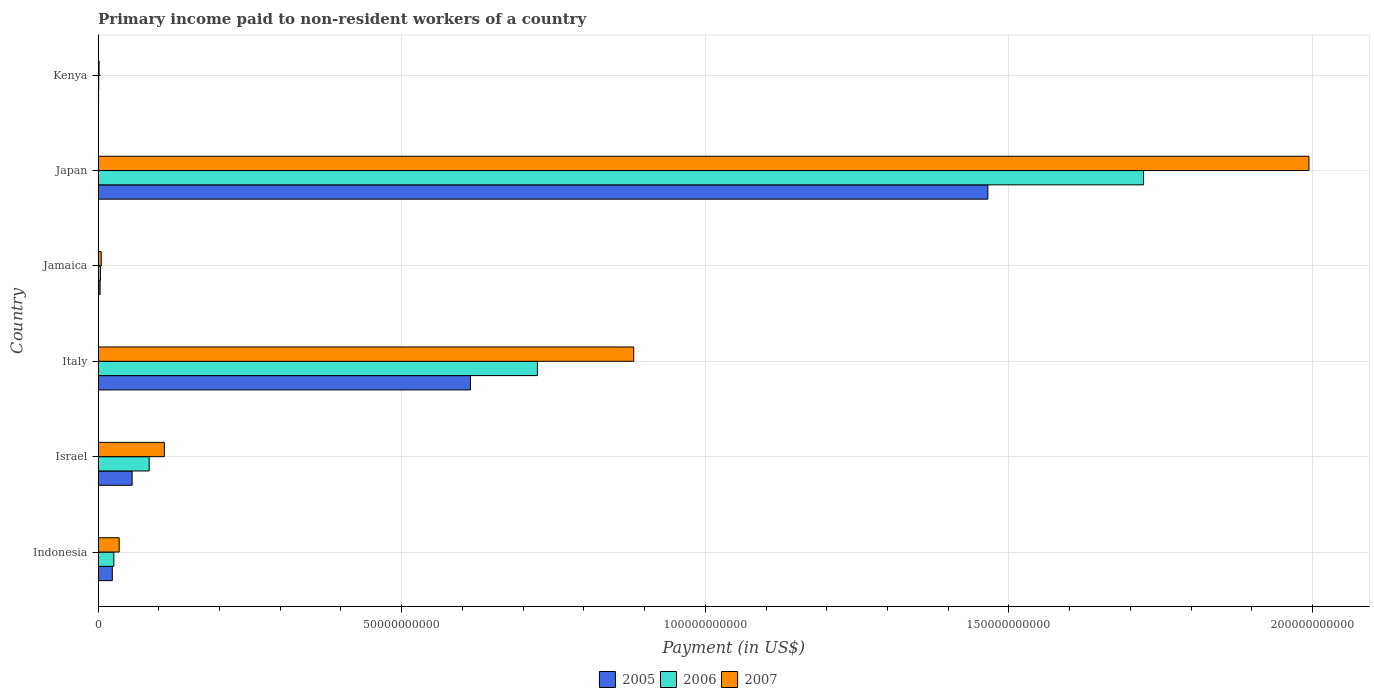How many different coloured bars are there?
Ensure brevity in your answer.  3. Are the number of bars per tick equal to the number of legend labels?
Offer a very short reply. Yes. Are the number of bars on each tick of the Y-axis equal?
Make the answer very short. Yes. How many bars are there on the 5th tick from the bottom?
Ensure brevity in your answer.  3. What is the label of the 5th group of bars from the top?
Your answer should be compact. Israel. In how many cases, is the number of bars for a given country not equal to the number of legend labels?
Your answer should be very brief. 0. What is the amount paid to workers in 2005 in Japan?
Your response must be concise. 1.47e+11. Across all countries, what is the maximum amount paid to workers in 2006?
Your answer should be compact. 1.72e+11. Across all countries, what is the minimum amount paid to workers in 2007?
Give a very brief answer. 1.61e+08. In which country was the amount paid to workers in 2006 maximum?
Keep it short and to the point. Japan. In which country was the amount paid to workers in 2005 minimum?
Provide a short and direct response. Kenya. What is the total amount paid to workers in 2005 in the graph?
Make the answer very short. 2.16e+11. What is the difference between the amount paid to workers in 2006 in Jamaica and that in Japan?
Provide a short and direct response. -1.72e+11. What is the difference between the amount paid to workers in 2005 in Israel and the amount paid to workers in 2006 in Kenya?
Provide a succinct answer. 5.50e+09. What is the average amount paid to workers in 2006 per country?
Ensure brevity in your answer.  4.27e+1. What is the difference between the amount paid to workers in 2006 and amount paid to workers in 2005 in Kenya?
Offer a terse response. 2.62e+07. What is the ratio of the amount paid to workers in 2005 in Italy to that in Japan?
Provide a short and direct response. 0.42. Is the amount paid to workers in 2007 in Indonesia less than that in Japan?
Offer a terse response. Yes. Is the difference between the amount paid to workers in 2006 in Jamaica and Kenya greater than the difference between the amount paid to workers in 2005 in Jamaica and Kenya?
Provide a short and direct response. Yes. What is the difference between the highest and the second highest amount paid to workers in 2005?
Your response must be concise. 8.52e+1. What is the difference between the highest and the lowest amount paid to workers in 2005?
Provide a succinct answer. 1.46e+11. In how many countries, is the amount paid to workers in 2006 greater than the average amount paid to workers in 2006 taken over all countries?
Your answer should be compact. 2. What does the 1st bar from the top in Israel represents?
Provide a short and direct response. 2007. What does the 3rd bar from the bottom in Kenya represents?
Your answer should be very brief. 2007. How many bars are there?
Your answer should be very brief. 18. Are all the bars in the graph horizontal?
Make the answer very short. Yes. How many countries are there in the graph?
Provide a short and direct response. 6. Does the graph contain grids?
Provide a succinct answer. Yes. Where does the legend appear in the graph?
Your answer should be very brief. Bottom center. How are the legend labels stacked?
Your answer should be compact. Horizontal. What is the title of the graph?
Provide a succinct answer. Primary income paid to non-resident workers of a country. Does "1976" appear as one of the legend labels in the graph?
Provide a short and direct response. No. What is the label or title of the X-axis?
Provide a short and direct response. Payment (in US$). What is the Payment (in US$) of 2005 in Indonesia?
Give a very brief answer. 2.34e+09. What is the Payment (in US$) of 2006 in Indonesia?
Your response must be concise. 2.59e+09. What is the Payment (in US$) of 2007 in Indonesia?
Your answer should be very brief. 3.47e+09. What is the Payment (in US$) of 2005 in Israel?
Your response must be concise. 5.60e+09. What is the Payment (in US$) of 2006 in Israel?
Provide a short and direct response. 8.41e+09. What is the Payment (in US$) in 2007 in Israel?
Offer a terse response. 1.09e+1. What is the Payment (in US$) in 2005 in Italy?
Your answer should be very brief. 6.13e+1. What is the Payment (in US$) in 2006 in Italy?
Provide a succinct answer. 7.24e+1. What is the Payment (in US$) in 2007 in Italy?
Provide a succinct answer. 8.82e+1. What is the Payment (in US$) of 2005 in Jamaica?
Give a very brief answer. 3.28e+08. What is the Payment (in US$) of 2006 in Jamaica?
Your answer should be very brief. 3.78e+08. What is the Payment (in US$) of 2007 in Jamaica?
Your answer should be compact. 5.21e+08. What is the Payment (in US$) in 2005 in Japan?
Make the answer very short. 1.47e+11. What is the Payment (in US$) in 2006 in Japan?
Offer a very short reply. 1.72e+11. What is the Payment (in US$) of 2007 in Japan?
Your answer should be very brief. 1.99e+11. What is the Payment (in US$) in 2005 in Kenya?
Your answer should be very brief. 7.33e+07. What is the Payment (in US$) in 2006 in Kenya?
Your answer should be compact. 9.94e+07. What is the Payment (in US$) in 2007 in Kenya?
Keep it short and to the point. 1.61e+08. Across all countries, what is the maximum Payment (in US$) in 2005?
Offer a very short reply. 1.47e+11. Across all countries, what is the maximum Payment (in US$) of 2006?
Keep it short and to the point. 1.72e+11. Across all countries, what is the maximum Payment (in US$) in 2007?
Give a very brief answer. 1.99e+11. Across all countries, what is the minimum Payment (in US$) of 2005?
Your answer should be compact. 7.33e+07. Across all countries, what is the minimum Payment (in US$) in 2006?
Your answer should be very brief. 9.94e+07. Across all countries, what is the minimum Payment (in US$) of 2007?
Provide a short and direct response. 1.61e+08. What is the total Payment (in US$) of 2005 in the graph?
Offer a terse response. 2.16e+11. What is the total Payment (in US$) in 2006 in the graph?
Make the answer very short. 2.56e+11. What is the total Payment (in US$) of 2007 in the graph?
Make the answer very short. 3.03e+11. What is the difference between the Payment (in US$) of 2005 in Indonesia and that in Israel?
Ensure brevity in your answer.  -3.26e+09. What is the difference between the Payment (in US$) of 2006 in Indonesia and that in Israel?
Your response must be concise. -5.82e+09. What is the difference between the Payment (in US$) of 2007 in Indonesia and that in Israel?
Ensure brevity in your answer.  -7.44e+09. What is the difference between the Payment (in US$) in 2005 in Indonesia and that in Italy?
Your answer should be compact. -5.90e+1. What is the difference between the Payment (in US$) in 2006 in Indonesia and that in Italy?
Offer a very short reply. -6.98e+1. What is the difference between the Payment (in US$) of 2007 in Indonesia and that in Italy?
Ensure brevity in your answer.  -8.47e+1. What is the difference between the Payment (in US$) in 2005 in Indonesia and that in Jamaica?
Provide a succinct answer. 2.01e+09. What is the difference between the Payment (in US$) of 2006 in Indonesia and that in Jamaica?
Your response must be concise. 2.21e+09. What is the difference between the Payment (in US$) of 2007 in Indonesia and that in Jamaica?
Give a very brief answer. 2.95e+09. What is the difference between the Payment (in US$) of 2005 in Indonesia and that in Japan?
Ensure brevity in your answer.  -1.44e+11. What is the difference between the Payment (in US$) of 2006 in Indonesia and that in Japan?
Give a very brief answer. -1.70e+11. What is the difference between the Payment (in US$) in 2007 in Indonesia and that in Japan?
Offer a terse response. -1.96e+11. What is the difference between the Payment (in US$) in 2005 in Indonesia and that in Kenya?
Your response must be concise. 2.26e+09. What is the difference between the Payment (in US$) of 2006 in Indonesia and that in Kenya?
Provide a short and direct response. 2.49e+09. What is the difference between the Payment (in US$) in 2007 in Indonesia and that in Kenya?
Offer a terse response. 3.31e+09. What is the difference between the Payment (in US$) of 2005 in Israel and that in Italy?
Your response must be concise. -5.57e+1. What is the difference between the Payment (in US$) in 2006 in Israel and that in Italy?
Your answer should be very brief. -6.39e+1. What is the difference between the Payment (in US$) of 2007 in Israel and that in Italy?
Your answer should be compact. -7.73e+1. What is the difference between the Payment (in US$) of 2005 in Israel and that in Jamaica?
Offer a terse response. 5.27e+09. What is the difference between the Payment (in US$) in 2006 in Israel and that in Jamaica?
Offer a terse response. 8.03e+09. What is the difference between the Payment (in US$) in 2007 in Israel and that in Jamaica?
Your answer should be very brief. 1.04e+1. What is the difference between the Payment (in US$) in 2005 in Israel and that in Japan?
Ensure brevity in your answer.  -1.41e+11. What is the difference between the Payment (in US$) of 2006 in Israel and that in Japan?
Keep it short and to the point. -1.64e+11. What is the difference between the Payment (in US$) in 2007 in Israel and that in Japan?
Give a very brief answer. -1.89e+11. What is the difference between the Payment (in US$) in 2005 in Israel and that in Kenya?
Your answer should be very brief. 5.53e+09. What is the difference between the Payment (in US$) in 2006 in Israel and that in Kenya?
Provide a succinct answer. 8.31e+09. What is the difference between the Payment (in US$) in 2007 in Israel and that in Kenya?
Ensure brevity in your answer.  1.07e+1. What is the difference between the Payment (in US$) in 2005 in Italy and that in Jamaica?
Offer a terse response. 6.10e+1. What is the difference between the Payment (in US$) of 2006 in Italy and that in Jamaica?
Offer a very short reply. 7.20e+1. What is the difference between the Payment (in US$) in 2007 in Italy and that in Jamaica?
Keep it short and to the point. 8.77e+1. What is the difference between the Payment (in US$) in 2005 in Italy and that in Japan?
Offer a terse response. -8.52e+1. What is the difference between the Payment (in US$) in 2006 in Italy and that in Japan?
Give a very brief answer. -9.98e+1. What is the difference between the Payment (in US$) in 2007 in Italy and that in Japan?
Your response must be concise. -1.11e+11. What is the difference between the Payment (in US$) of 2005 in Italy and that in Kenya?
Make the answer very short. 6.12e+1. What is the difference between the Payment (in US$) in 2006 in Italy and that in Kenya?
Provide a short and direct response. 7.23e+1. What is the difference between the Payment (in US$) of 2007 in Italy and that in Kenya?
Your response must be concise. 8.81e+1. What is the difference between the Payment (in US$) in 2005 in Jamaica and that in Japan?
Your answer should be compact. -1.46e+11. What is the difference between the Payment (in US$) of 2006 in Jamaica and that in Japan?
Offer a very short reply. -1.72e+11. What is the difference between the Payment (in US$) of 2007 in Jamaica and that in Japan?
Provide a short and direct response. -1.99e+11. What is the difference between the Payment (in US$) in 2005 in Jamaica and that in Kenya?
Keep it short and to the point. 2.55e+08. What is the difference between the Payment (in US$) in 2006 in Jamaica and that in Kenya?
Keep it short and to the point. 2.79e+08. What is the difference between the Payment (in US$) in 2007 in Jamaica and that in Kenya?
Provide a short and direct response. 3.60e+08. What is the difference between the Payment (in US$) of 2005 in Japan and that in Kenya?
Provide a succinct answer. 1.46e+11. What is the difference between the Payment (in US$) in 2006 in Japan and that in Kenya?
Your answer should be very brief. 1.72e+11. What is the difference between the Payment (in US$) in 2007 in Japan and that in Kenya?
Your answer should be compact. 1.99e+11. What is the difference between the Payment (in US$) of 2005 in Indonesia and the Payment (in US$) of 2006 in Israel?
Your response must be concise. -6.07e+09. What is the difference between the Payment (in US$) of 2005 in Indonesia and the Payment (in US$) of 2007 in Israel?
Your response must be concise. -8.57e+09. What is the difference between the Payment (in US$) of 2006 in Indonesia and the Payment (in US$) of 2007 in Israel?
Keep it short and to the point. -8.32e+09. What is the difference between the Payment (in US$) of 2005 in Indonesia and the Payment (in US$) of 2006 in Italy?
Keep it short and to the point. -7.00e+1. What is the difference between the Payment (in US$) of 2005 in Indonesia and the Payment (in US$) of 2007 in Italy?
Give a very brief answer. -8.59e+1. What is the difference between the Payment (in US$) of 2006 in Indonesia and the Payment (in US$) of 2007 in Italy?
Provide a short and direct response. -8.56e+1. What is the difference between the Payment (in US$) of 2005 in Indonesia and the Payment (in US$) of 2006 in Jamaica?
Offer a very short reply. 1.96e+09. What is the difference between the Payment (in US$) in 2005 in Indonesia and the Payment (in US$) in 2007 in Jamaica?
Keep it short and to the point. 1.82e+09. What is the difference between the Payment (in US$) of 2006 in Indonesia and the Payment (in US$) of 2007 in Jamaica?
Provide a succinct answer. 2.07e+09. What is the difference between the Payment (in US$) of 2005 in Indonesia and the Payment (in US$) of 2006 in Japan?
Keep it short and to the point. -1.70e+11. What is the difference between the Payment (in US$) in 2005 in Indonesia and the Payment (in US$) in 2007 in Japan?
Keep it short and to the point. -1.97e+11. What is the difference between the Payment (in US$) of 2006 in Indonesia and the Payment (in US$) of 2007 in Japan?
Offer a very short reply. -1.97e+11. What is the difference between the Payment (in US$) in 2005 in Indonesia and the Payment (in US$) in 2006 in Kenya?
Provide a succinct answer. 2.24e+09. What is the difference between the Payment (in US$) of 2005 in Indonesia and the Payment (in US$) of 2007 in Kenya?
Provide a short and direct response. 2.18e+09. What is the difference between the Payment (in US$) in 2006 in Indonesia and the Payment (in US$) in 2007 in Kenya?
Offer a very short reply. 2.43e+09. What is the difference between the Payment (in US$) in 2005 in Israel and the Payment (in US$) in 2006 in Italy?
Provide a short and direct response. -6.67e+1. What is the difference between the Payment (in US$) of 2005 in Israel and the Payment (in US$) of 2007 in Italy?
Provide a succinct answer. -8.26e+1. What is the difference between the Payment (in US$) of 2006 in Israel and the Payment (in US$) of 2007 in Italy?
Offer a very short reply. -7.98e+1. What is the difference between the Payment (in US$) of 2005 in Israel and the Payment (in US$) of 2006 in Jamaica?
Your answer should be very brief. 5.22e+09. What is the difference between the Payment (in US$) in 2005 in Israel and the Payment (in US$) in 2007 in Jamaica?
Give a very brief answer. 5.08e+09. What is the difference between the Payment (in US$) in 2006 in Israel and the Payment (in US$) in 2007 in Jamaica?
Your response must be concise. 7.89e+09. What is the difference between the Payment (in US$) of 2005 in Israel and the Payment (in US$) of 2006 in Japan?
Make the answer very short. -1.67e+11. What is the difference between the Payment (in US$) in 2005 in Israel and the Payment (in US$) in 2007 in Japan?
Give a very brief answer. -1.94e+11. What is the difference between the Payment (in US$) in 2006 in Israel and the Payment (in US$) in 2007 in Japan?
Offer a very short reply. -1.91e+11. What is the difference between the Payment (in US$) of 2005 in Israel and the Payment (in US$) of 2006 in Kenya?
Make the answer very short. 5.50e+09. What is the difference between the Payment (in US$) in 2005 in Israel and the Payment (in US$) in 2007 in Kenya?
Offer a terse response. 5.44e+09. What is the difference between the Payment (in US$) of 2006 in Israel and the Payment (in US$) of 2007 in Kenya?
Provide a succinct answer. 8.25e+09. What is the difference between the Payment (in US$) of 2005 in Italy and the Payment (in US$) of 2006 in Jamaica?
Your answer should be compact. 6.09e+1. What is the difference between the Payment (in US$) in 2005 in Italy and the Payment (in US$) in 2007 in Jamaica?
Your response must be concise. 6.08e+1. What is the difference between the Payment (in US$) in 2006 in Italy and the Payment (in US$) in 2007 in Jamaica?
Your answer should be compact. 7.18e+1. What is the difference between the Payment (in US$) of 2005 in Italy and the Payment (in US$) of 2006 in Japan?
Make the answer very short. -1.11e+11. What is the difference between the Payment (in US$) in 2005 in Italy and the Payment (in US$) in 2007 in Japan?
Your response must be concise. -1.38e+11. What is the difference between the Payment (in US$) in 2006 in Italy and the Payment (in US$) in 2007 in Japan?
Offer a terse response. -1.27e+11. What is the difference between the Payment (in US$) in 2005 in Italy and the Payment (in US$) in 2006 in Kenya?
Make the answer very short. 6.12e+1. What is the difference between the Payment (in US$) of 2005 in Italy and the Payment (in US$) of 2007 in Kenya?
Your response must be concise. 6.12e+1. What is the difference between the Payment (in US$) of 2006 in Italy and the Payment (in US$) of 2007 in Kenya?
Provide a short and direct response. 7.22e+1. What is the difference between the Payment (in US$) of 2005 in Jamaica and the Payment (in US$) of 2006 in Japan?
Your answer should be compact. -1.72e+11. What is the difference between the Payment (in US$) of 2005 in Jamaica and the Payment (in US$) of 2007 in Japan?
Ensure brevity in your answer.  -1.99e+11. What is the difference between the Payment (in US$) in 2006 in Jamaica and the Payment (in US$) in 2007 in Japan?
Offer a terse response. -1.99e+11. What is the difference between the Payment (in US$) in 2005 in Jamaica and the Payment (in US$) in 2006 in Kenya?
Make the answer very short. 2.29e+08. What is the difference between the Payment (in US$) in 2005 in Jamaica and the Payment (in US$) in 2007 in Kenya?
Your answer should be very brief. 1.67e+08. What is the difference between the Payment (in US$) of 2006 in Jamaica and the Payment (in US$) of 2007 in Kenya?
Provide a short and direct response. 2.18e+08. What is the difference between the Payment (in US$) of 2005 in Japan and the Payment (in US$) of 2006 in Kenya?
Offer a terse response. 1.46e+11. What is the difference between the Payment (in US$) in 2005 in Japan and the Payment (in US$) in 2007 in Kenya?
Your answer should be compact. 1.46e+11. What is the difference between the Payment (in US$) of 2006 in Japan and the Payment (in US$) of 2007 in Kenya?
Provide a short and direct response. 1.72e+11. What is the average Payment (in US$) of 2005 per country?
Keep it short and to the point. 3.60e+1. What is the average Payment (in US$) in 2006 per country?
Give a very brief answer. 4.27e+1. What is the average Payment (in US$) of 2007 per country?
Ensure brevity in your answer.  5.04e+1. What is the difference between the Payment (in US$) in 2005 and Payment (in US$) in 2006 in Indonesia?
Ensure brevity in your answer.  -2.50e+08. What is the difference between the Payment (in US$) of 2005 and Payment (in US$) of 2007 in Indonesia?
Provide a succinct answer. -1.13e+09. What is the difference between the Payment (in US$) in 2006 and Payment (in US$) in 2007 in Indonesia?
Give a very brief answer. -8.82e+08. What is the difference between the Payment (in US$) in 2005 and Payment (in US$) in 2006 in Israel?
Offer a very short reply. -2.81e+09. What is the difference between the Payment (in US$) of 2005 and Payment (in US$) of 2007 in Israel?
Give a very brief answer. -5.31e+09. What is the difference between the Payment (in US$) in 2006 and Payment (in US$) in 2007 in Israel?
Keep it short and to the point. -2.50e+09. What is the difference between the Payment (in US$) in 2005 and Payment (in US$) in 2006 in Italy?
Give a very brief answer. -1.10e+1. What is the difference between the Payment (in US$) of 2005 and Payment (in US$) of 2007 in Italy?
Your answer should be compact. -2.69e+1. What is the difference between the Payment (in US$) of 2006 and Payment (in US$) of 2007 in Italy?
Offer a terse response. -1.59e+1. What is the difference between the Payment (in US$) of 2005 and Payment (in US$) of 2006 in Jamaica?
Ensure brevity in your answer.  -5.05e+07. What is the difference between the Payment (in US$) in 2005 and Payment (in US$) in 2007 in Jamaica?
Your answer should be very brief. -1.93e+08. What is the difference between the Payment (in US$) in 2006 and Payment (in US$) in 2007 in Jamaica?
Provide a short and direct response. -1.42e+08. What is the difference between the Payment (in US$) in 2005 and Payment (in US$) in 2006 in Japan?
Ensure brevity in your answer.  -2.56e+1. What is the difference between the Payment (in US$) of 2005 and Payment (in US$) of 2007 in Japan?
Ensure brevity in your answer.  -5.29e+1. What is the difference between the Payment (in US$) of 2006 and Payment (in US$) of 2007 in Japan?
Ensure brevity in your answer.  -2.72e+1. What is the difference between the Payment (in US$) in 2005 and Payment (in US$) in 2006 in Kenya?
Provide a succinct answer. -2.62e+07. What is the difference between the Payment (in US$) of 2005 and Payment (in US$) of 2007 in Kenya?
Make the answer very short. -8.73e+07. What is the difference between the Payment (in US$) of 2006 and Payment (in US$) of 2007 in Kenya?
Your answer should be very brief. -6.12e+07. What is the ratio of the Payment (in US$) of 2005 in Indonesia to that in Israel?
Offer a very short reply. 0.42. What is the ratio of the Payment (in US$) of 2006 in Indonesia to that in Israel?
Make the answer very short. 0.31. What is the ratio of the Payment (in US$) in 2007 in Indonesia to that in Israel?
Your answer should be very brief. 0.32. What is the ratio of the Payment (in US$) in 2005 in Indonesia to that in Italy?
Your response must be concise. 0.04. What is the ratio of the Payment (in US$) of 2006 in Indonesia to that in Italy?
Your answer should be compact. 0.04. What is the ratio of the Payment (in US$) in 2007 in Indonesia to that in Italy?
Your response must be concise. 0.04. What is the ratio of the Payment (in US$) in 2005 in Indonesia to that in Jamaica?
Your answer should be very brief. 7.13. What is the ratio of the Payment (in US$) in 2006 in Indonesia to that in Jamaica?
Provide a succinct answer. 6.84. What is the ratio of the Payment (in US$) in 2007 in Indonesia to that in Jamaica?
Offer a very short reply. 6.66. What is the ratio of the Payment (in US$) in 2005 in Indonesia to that in Japan?
Make the answer very short. 0.02. What is the ratio of the Payment (in US$) of 2006 in Indonesia to that in Japan?
Provide a short and direct response. 0.01. What is the ratio of the Payment (in US$) in 2007 in Indonesia to that in Japan?
Keep it short and to the point. 0.02. What is the ratio of the Payment (in US$) in 2005 in Indonesia to that in Kenya?
Provide a short and direct response. 31.91. What is the ratio of the Payment (in US$) in 2006 in Indonesia to that in Kenya?
Offer a terse response. 26.02. What is the ratio of the Payment (in US$) of 2007 in Indonesia to that in Kenya?
Offer a very short reply. 21.6. What is the ratio of the Payment (in US$) of 2005 in Israel to that in Italy?
Provide a short and direct response. 0.09. What is the ratio of the Payment (in US$) in 2006 in Israel to that in Italy?
Give a very brief answer. 0.12. What is the ratio of the Payment (in US$) in 2007 in Israel to that in Italy?
Ensure brevity in your answer.  0.12. What is the ratio of the Payment (in US$) of 2005 in Israel to that in Jamaica?
Make the answer very short. 17.08. What is the ratio of the Payment (in US$) in 2006 in Israel to that in Jamaica?
Give a very brief answer. 22.22. What is the ratio of the Payment (in US$) in 2007 in Israel to that in Jamaica?
Offer a very short reply. 20.95. What is the ratio of the Payment (in US$) of 2005 in Israel to that in Japan?
Provide a short and direct response. 0.04. What is the ratio of the Payment (in US$) of 2006 in Israel to that in Japan?
Provide a short and direct response. 0.05. What is the ratio of the Payment (in US$) of 2007 in Israel to that in Japan?
Your answer should be very brief. 0.05. What is the ratio of the Payment (in US$) in 2005 in Israel to that in Kenya?
Offer a terse response. 76.44. What is the ratio of the Payment (in US$) of 2006 in Israel to that in Kenya?
Keep it short and to the point. 84.57. What is the ratio of the Payment (in US$) of 2007 in Israel to that in Kenya?
Your answer should be very brief. 67.92. What is the ratio of the Payment (in US$) of 2005 in Italy to that in Jamaica?
Offer a very short reply. 187. What is the ratio of the Payment (in US$) of 2006 in Italy to that in Jamaica?
Keep it short and to the point. 191.2. What is the ratio of the Payment (in US$) of 2007 in Italy to that in Jamaica?
Give a very brief answer. 169.4. What is the ratio of the Payment (in US$) of 2005 in Italy to that in Japan?
Your response must be concise. 0.42. What is the ratio of the Payment (in US$) of 2006 in Italy to that in Japan?
Ensure brevity in your answer.  0.42. What is the ratio of the Payment (in US$) in 2007 in Italy to that in Japan?
Give a very brief answer. 0.44. What is the ratio of the Payment (in US$) of 2005 in Italy to that in Kenya?
Make the answer very short. 836.96. What is the ratio of the Payment (in US$) in 2006 in Italy to that in Kenya?
Provide a succinct answer. 727.71. What is the ratio of the Payment (in US$) in 2007 in Italy to that in Kenya?
Provide a succinct answer. 549.23. What is the ratio of the Payment (in US$) of 2005 in Jamaica to that in Japan?
Ensure brevity in your answer.  0. What is the ratio of the Payment (in US$) in 2006 in Jamaica to that in Japan?
Provide a succinct answer. 0. What is the ratio of the Payment (in US$) of 2007 in Jamaica to that in Japan?
Ensure brevity in your answer.  0. What is the ratio of the Payment (in US$) of 2005 in Jamaica to that in Kenya?
Make the answer very short. 4.48. What is the ratio of the Payment (in US$) in 2006 in Jamaica to that in Kenya?
Ensure brevity in your answer.  3.81. What is the ratio of the Payment (in US$) of 2007 in Jamaica to that in Kenya?
Provide a short and direct response. 3.24. What is the ratio of the Payment (in US$) of 2005 in Japan to that in Kenya?
Offer a terse response. 2000.05. What is the ratio of the Payment (in US$) in 2006 in Japan to that in Kenya?
Provide a succinct answer. 1731.85. What is the ratio of the Payment (in US$) of 2007 in Japan to that in Kenya?
Keep it short and to the point. 1241.66. What is the difference between the highest and the second highest Payment (in US$) in 2005?
Offer a very short reply. 8.52e+1. What is the difference between the highest and the second highest Payment (in US$) in 2006?
Provide a short and direct response. 9.98e+1. What is the difference between the highest and the second highest Payment (in US$) of 2007?
Your answer should be compact. 1.11e+11. What is the difference between the highest and the lowest Payment (in US$) of 2005?
Your answer should be very brief. 1.46e+11. What is the difference between the highest and the lowest Payment (in US$) of 2006?
Offer a very short reply. 1.72e+11. What is the difference between the highest and the lowest Payment (in US$) of 2007?
Ensure brevity in your answer.  1.99e+11. 